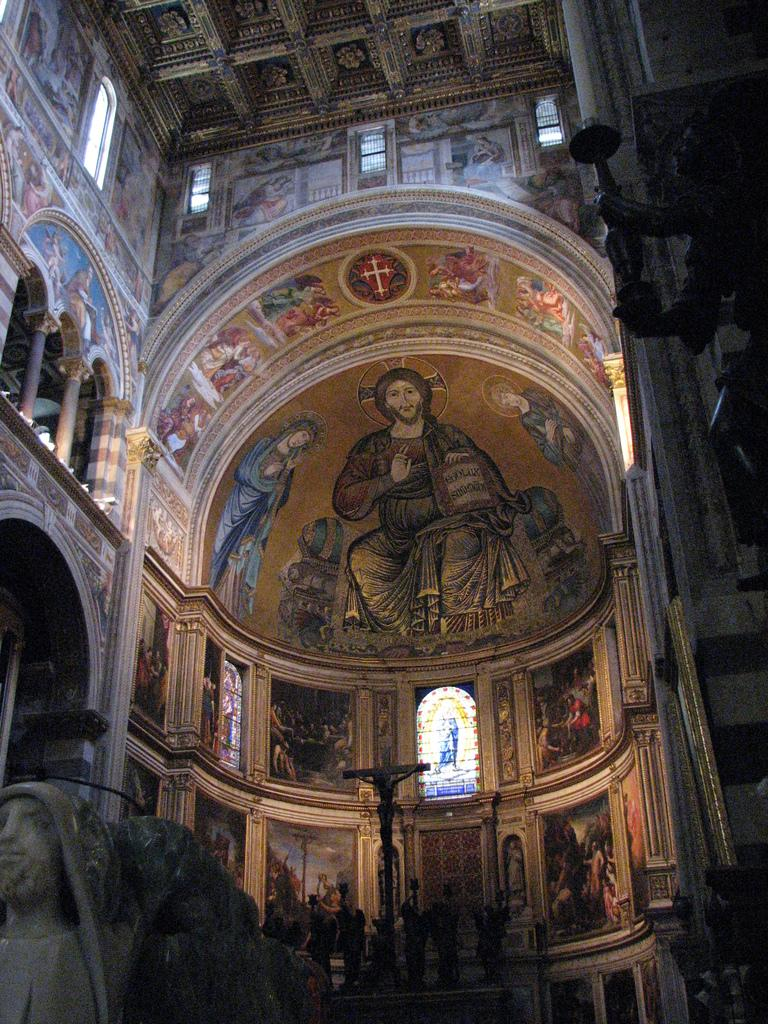What is the main subject in the foreground of the image? There is a building in the foreground of the image. What decorative elements can be seen on the building? Sculptures and wall paintings are visible on the building. What is happening at the bottom of the image? There is a crowd at the bottom of the image. Where was the image taken? The image was taken inside a building. What type of nut is being rewarded by the trucks in the image? There are no nuts or trucks present in the image; it features a building with sculptures and wall paintings, as well as a crowd at the bottom. 